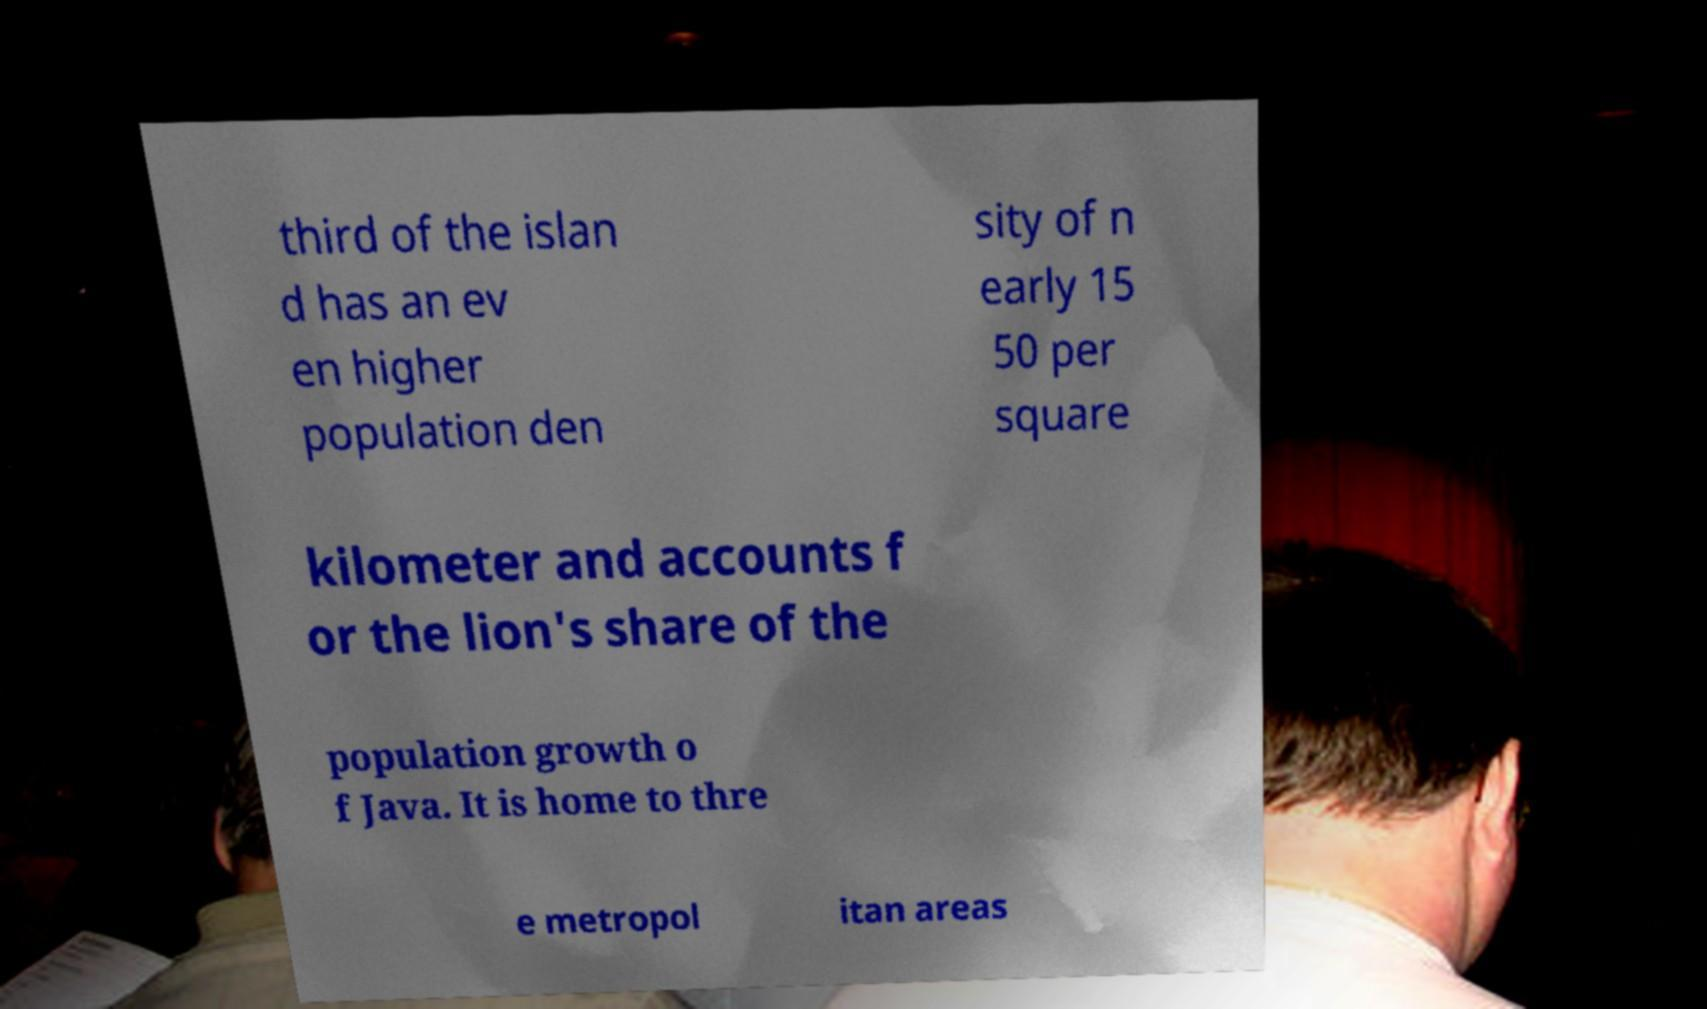Could you assist in decoding the text presented in this image and type it out clearly? third of the islan d has an ev en higher population den sity of n early 15 50 per square kilometer and accounts f or the lion's share of the population growth o f Java. It is home to thre e metropol itan areas 